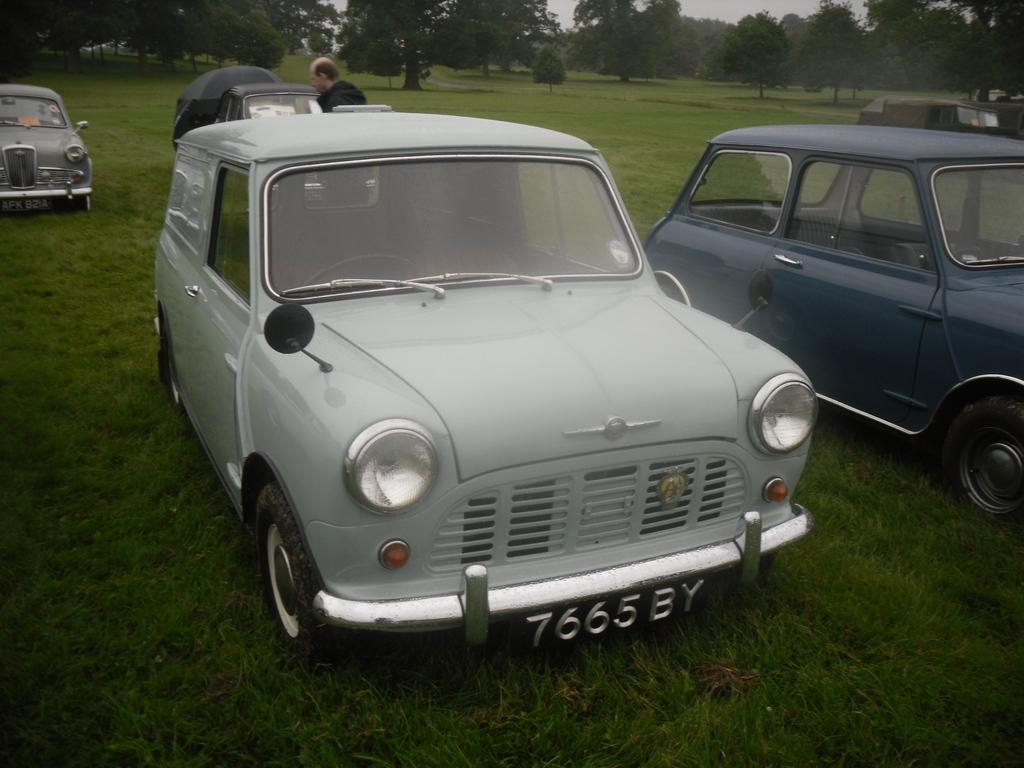What type of vehicles can be seen in the image? There are cars in the image. What is the man on the ground doing in the image? The man on the ground is not performing any visible actions in the image. What can be seen in the distance in the image? There are trees in the background of the image. What is visible above the trees in the image? The sky is visible in the background of the image. How many dolls are sitting on the cars in the image? There are no dolls present in the image. What type of vacation is the man on the ground planning in the image? There is no indication of a vacation or any planning in the image. 